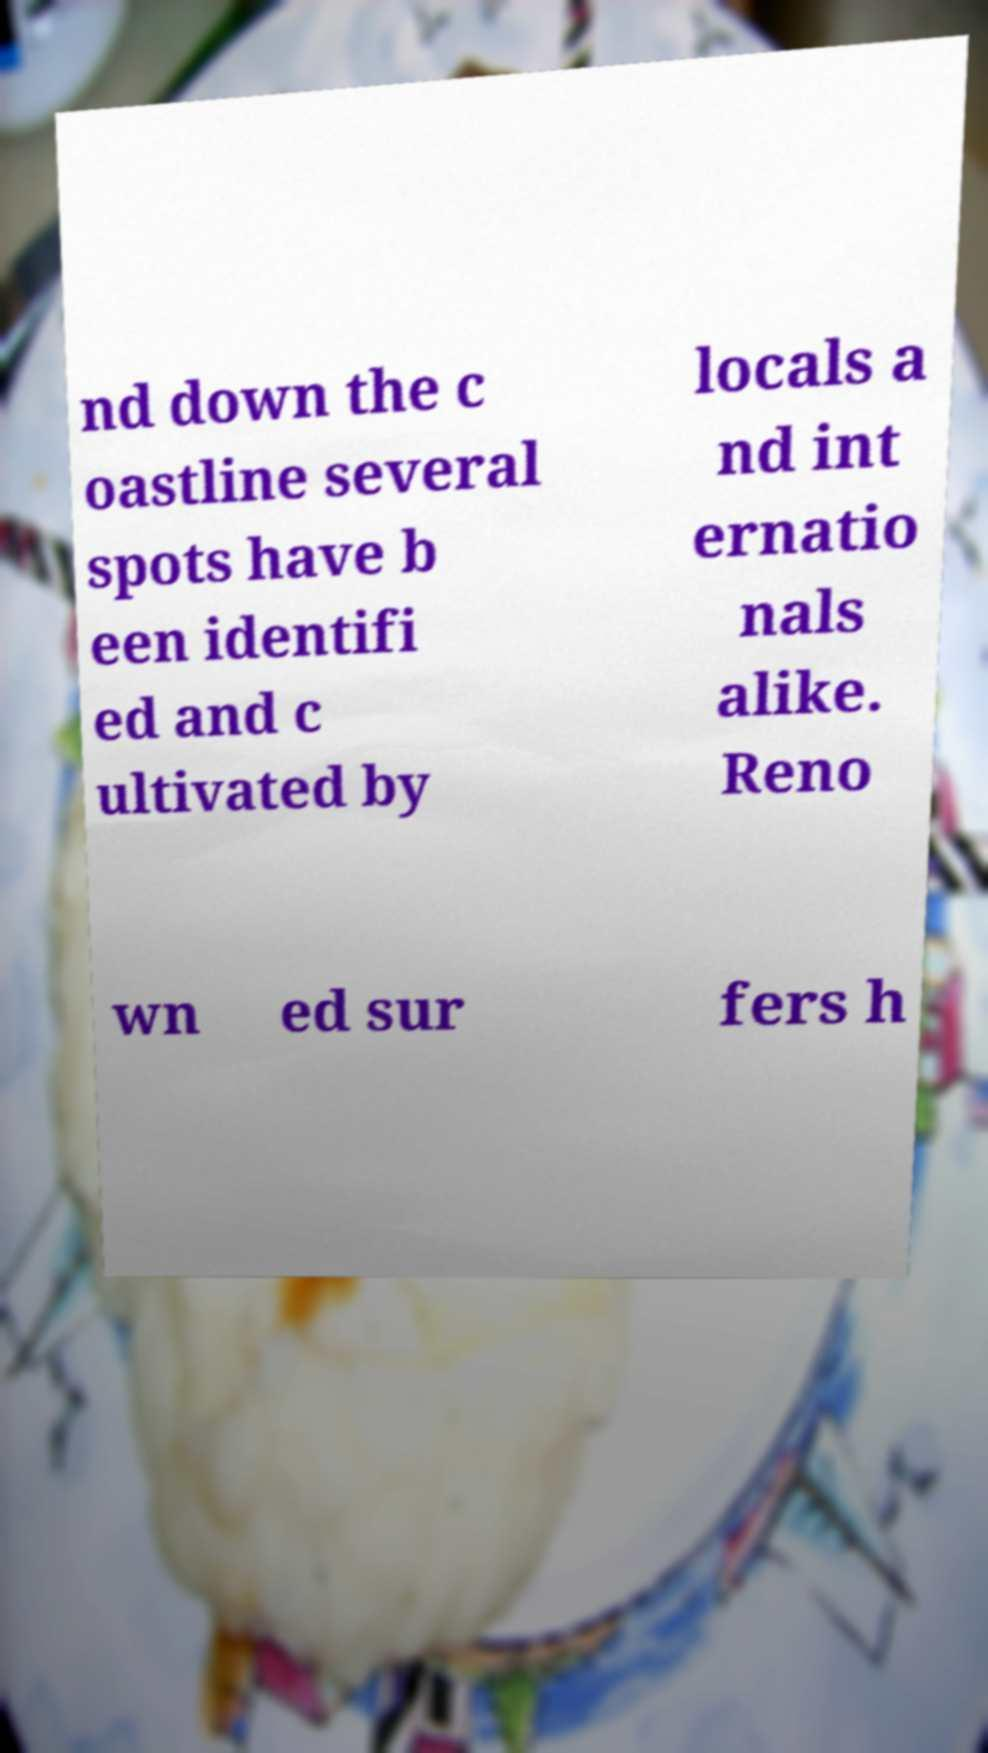There's text embedded in this image that I need extracted. Can you transcribe it verbatim? nd down the c oastline several spots have b een identifi ed and c ultivated by locals a nd int ernatio nals alike. Reno wn ed sur fers h 